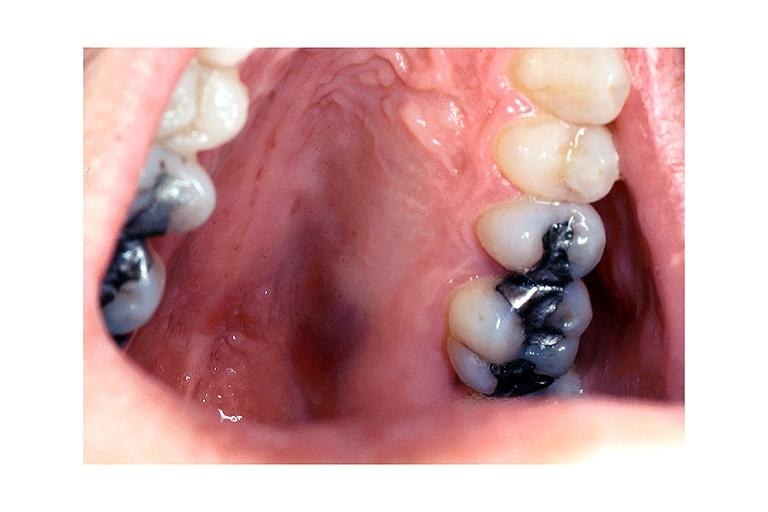what is present?
Answer the question using a single word or phrase. Oral 